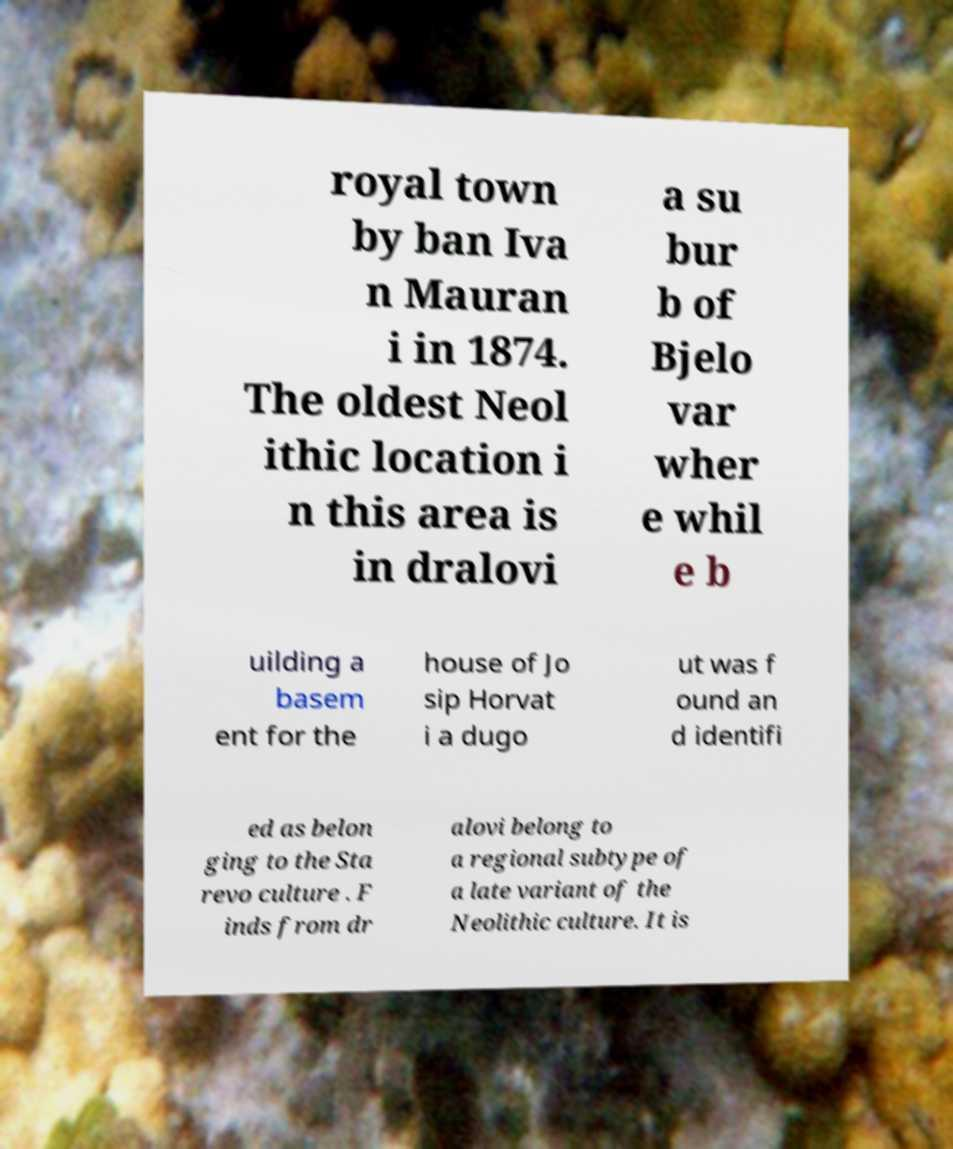Can you accurately transcribe the text from the provided image for me? royal town by ban Iva n Mauran i in 1874. The oldest Neol ithic location i n this area is in dralovi a su bur b of Bjelo var wher e whil e b uilding a basem ent for the house of Jo sip Horvat i a dugo ut was f ound an d identifi ed as belon ging to the Sta revo culture . F inds from dr alovi belong to a regional subtype of a late variant of the Neolithic culture. It is 